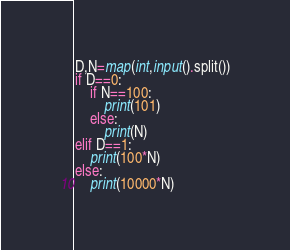<code> <loc_0><loc_0><loc_500><loc_500><_Python_>D,N=map(int,input().split())
if D==0:
    if N==100:
        print(101)
    else:
	    print(N)
elif D==1:
	print(100*N)
else:
	print(10000*N)</code> 